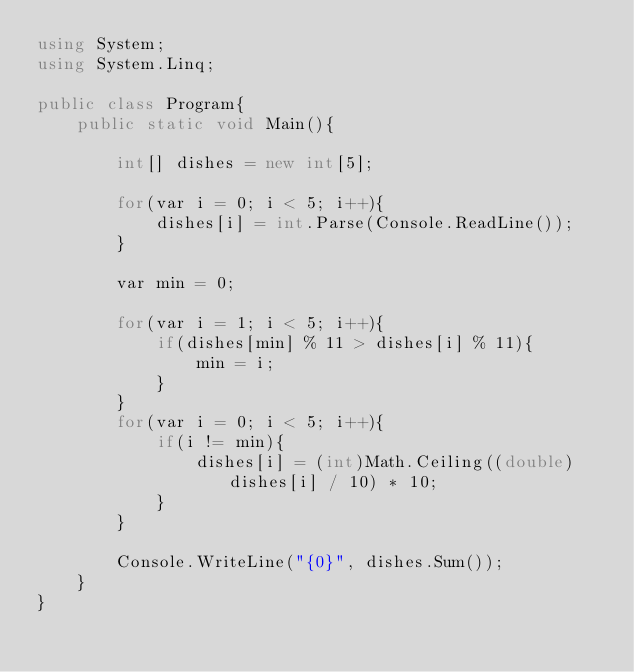<code> <loc_0><loc_0><loc_500><loc_500><_C#_>using System;
using System.Linq;

public class Program{
    public static void Main(){
        
        int[] dishes = new int[5];
        
        for(var i = 0; i < 5; i++){
            dishes[i] = int.Parse(Console.ReadLine());
        }
        
        var min = 0;
        
        for(var i = 1; i < 5; i++){
            if(dishes[min] % 11 > dishes[i] % 11){
                min = i;
            }
        }
        for(var i = 0; i < 5; i++){
            if(i != min){
                dishes[i] = (int)Math.Ceiling((double)dishes[i] / 10) * 10;
            }
        }
        
        Console.WriteLine("{0}", dishes.Sum());
    }
}</code> 